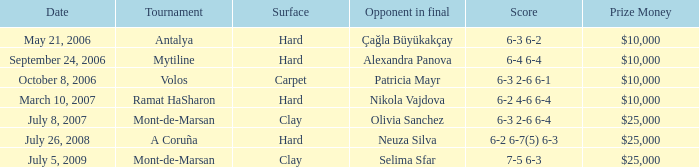What is the score of the match on September 24, 2006? 6-4 6-4. 